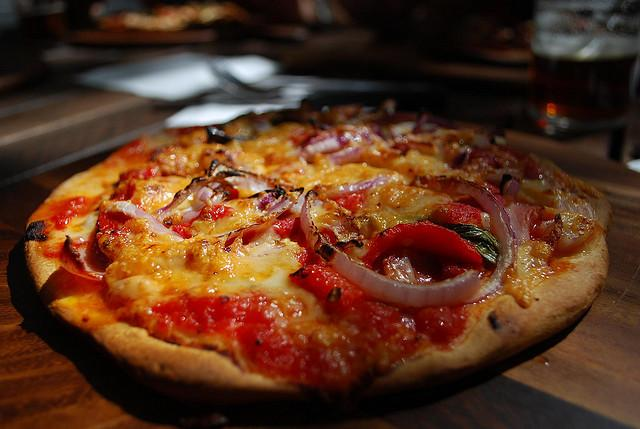The white round item on top of this food is part of what other food item?

Choices:
A) flounder
B) tuna
C) onion rings
D) calamari onion rings 